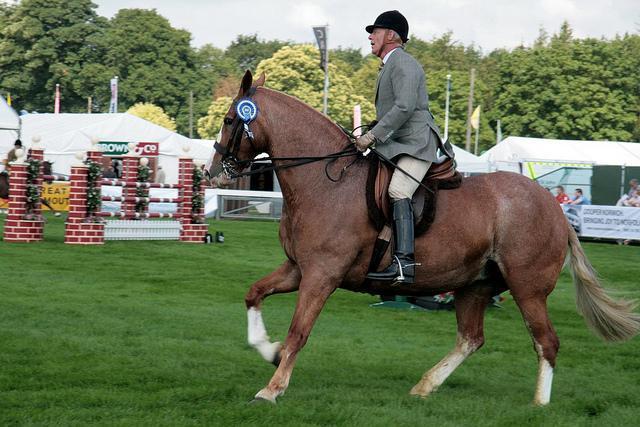What does the man have on?
From the following set of four choices, select the accurate answer to respond to the question.
Options: Bow tie, hat, scarf, suspenders. Hat. 